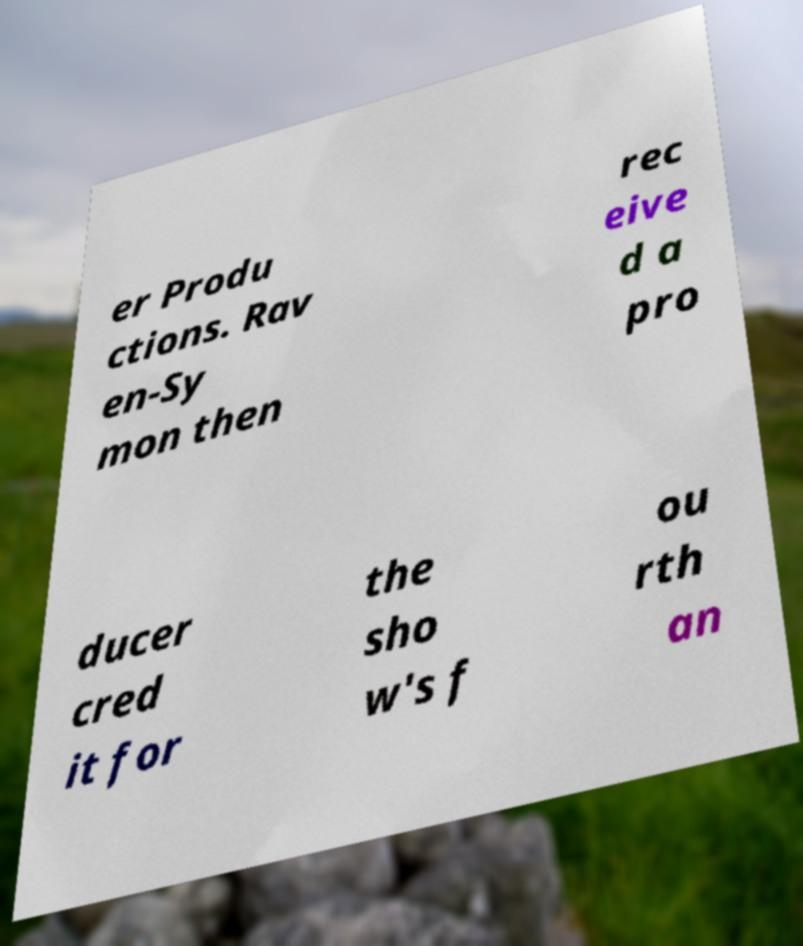For documentation purposes, I need the text within this image transcribed. Could you provide that? er Produ ctions. Rav en-Sy mon then rec eive d a pro ducer cred it for the sho w's f ou rth an 